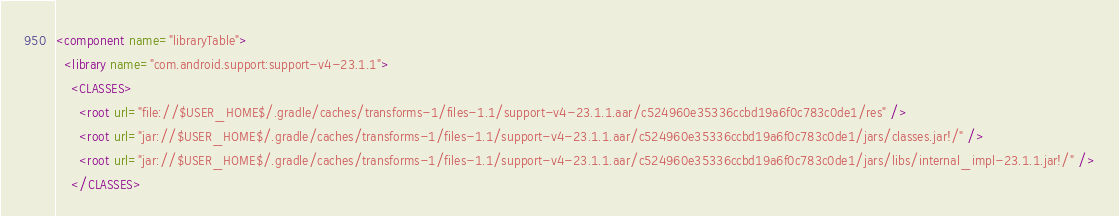Convert code to text. <code><loc_0><loc_0><loc_500><loc_500><_XML_><component name="libraryTable">
  <library name="com.android.support:support-v4-23.1.1">
    <CLASSES>
      <root url="file://$USER_HOME$/.gradle/caches/transforms-1/files-1.1/support-v4-23.1.1.aar/c524960e35336ccbd19a6f0c783c0de1/res" />
      <root url="jar://$USER_HOME$/.gradle/caches/transforms-1/files-1.1/support-v4-23.1.1.aar/c524960e35336ccbd19a6f0c783c0de1/jars/classes.jar!/" />
      <root url="jar://$USER_HOME$/.gradle/caches/transforms-1/files-1.1/support-v4-23.1.1.aar/c524960e35336ccbd19a6f0c783c0de1/jars/libs/internal_impl-23.1.1.jar!/" />
    </CLASSES></code> 